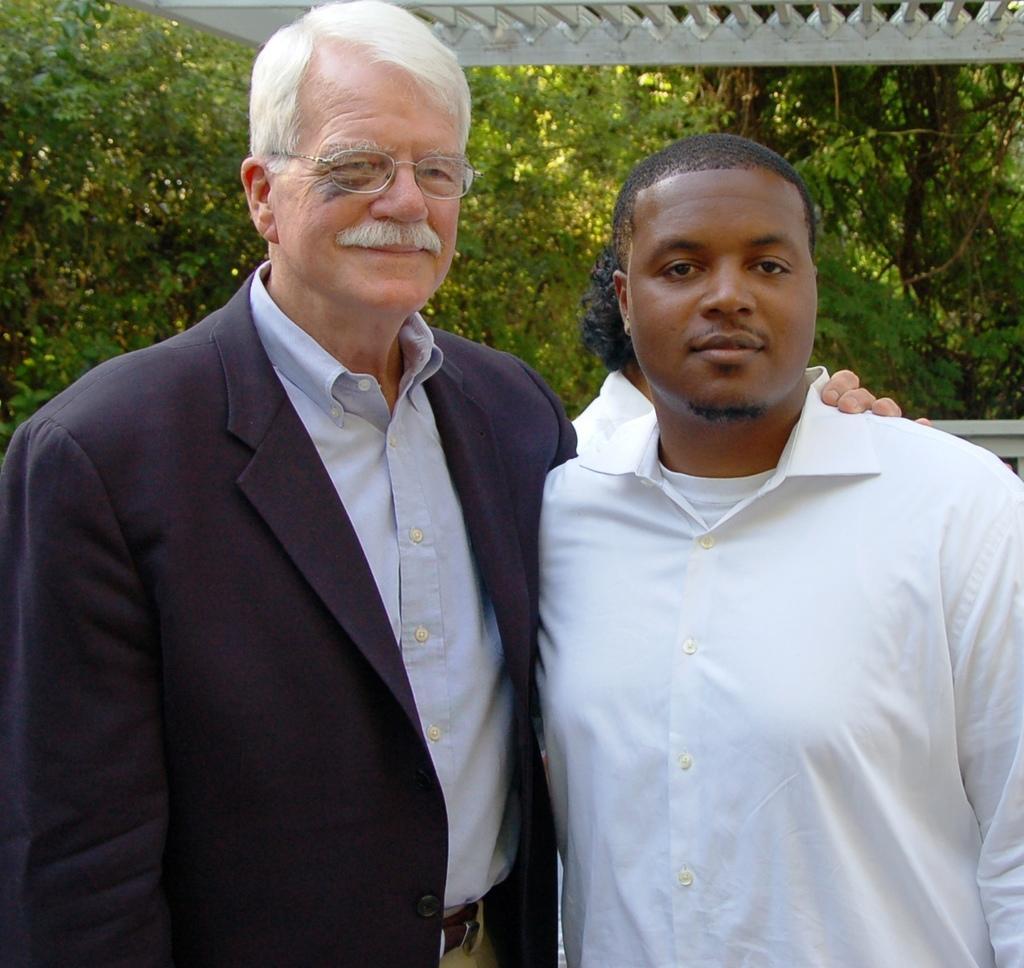Could you give a brief overview of what you see in this image? In this image there are two men are standing. They are smiling. The man to the left is wearing a blazer. Behind them there are leaves of trees. At the top there are rods to the ceiling. 